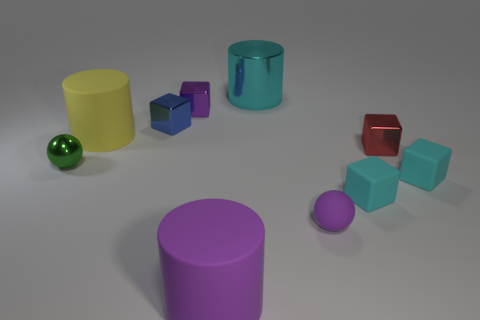Subtract all rubber cylinders. How many cylinders are left? 1 Subtract all purple cubes. How many cubes are left? 4 Subtract all spheres. How many objects are left? 8 Subtract 1 cylinders. How many cylinders are left? 2 Subtract all red cylinders. How many gray cubes are left? 0 Subtract all large cyan shiny cylinders. Subtract all small gray rubber things. How many objects are left? 9 Add 4 tiny cyan rubber blocks. How many tiny cyan rubber blocks are left? 6 Add 8 big green matte objects. How many big green matte objects exist? 8 Subtract 1 purple cylinders. How many objects are left? 9 Subtract all gray cylinders. Subtract all green blocks. How many cylinders are left? 3 